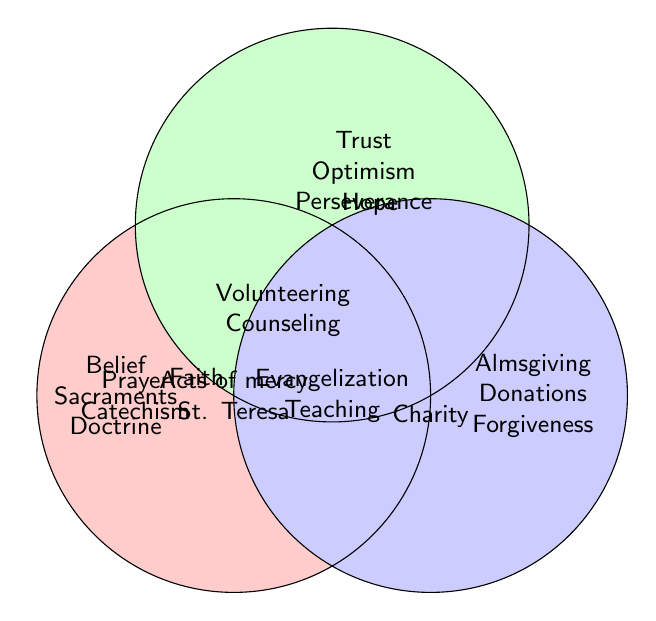What virtues overlap between Faith and Charity? The intersection of Faith and Charity lists concepts that belong to both categories. By looking at the overlap section between the Faith and Charity circles, we see "Prayer" and "Evangelization".
Answer: Prayer, Evangelization What are the unique virtues associated with Hope alone? The circle representing only Hope without overlapping others includes virtues solely attributed to Hope. The terms listed here are "Trust in divine plan", "Optimism", and "Perseverance".
Answer: Trust in divine plan, Optimism, Perseverance Which virtue is common to Faith, Hope, and Charity? The center of the Venn diagram, where all three circles overlap, contains virtues that are shared among Faith, Hope, and Charity. This section lists "Acts of mercy" and "St. Teresa of Calcutta".
Answer: Acts of mercy, St. Teresa of Calcutta Identify the virtues that overlap between Hope and Charity but not Faith. To determine what overlaps between Hope and Charity but not in Faith, we look at the intersection between Hope and Charity without including Faith. These virtues are "Volunteering" and "Counseling".
Answer: Volunteering, Counseling List all virtues associated uniquely with Faith without any overlaps. The section solely within the Faith circle without any overlaps shows virtues unique to Faith. These virtues are "Belief in God", "Sacraments", "Doctrine", and "Creed".
Answer: Belief in God, Sacraments, Doctrine, Creed Name all the virtues shared between Faith, Hope, but not Charity. To find shared values between Faith and Hope without including Charity, we locate the intersection excluding Charity. The shared virtues are "Prayer" and "Catechism".
Answer: Prayer, Catechism What virtue is common to both Hope and Faith but not related to Charity? The intersection area between the Faith and Hope circles that does not intersect with Charity includes "Prayer" and "Catechism".
Answer: Prayer, Catechism Which virtue is linked to all three categories, and also associated with a notable religious figure? The central area where all three circles overlap lists "Acts of mercy" and specifically "St. Teresa of Calcutta" as notable figures or examples.
Answer: St. Teresa of Calcutta 